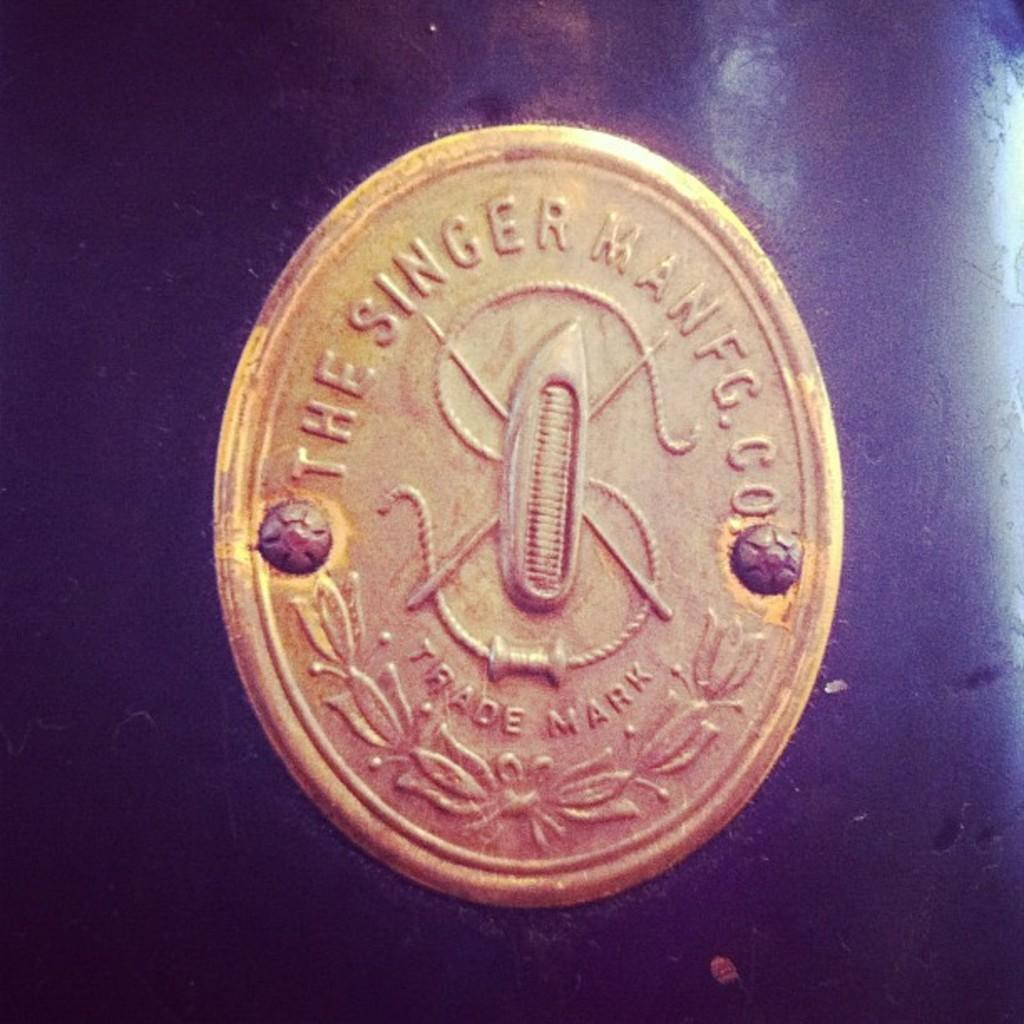<image>
Create a compact narrative representing the image presented. A gold coin that says The Singer Man F.G. 